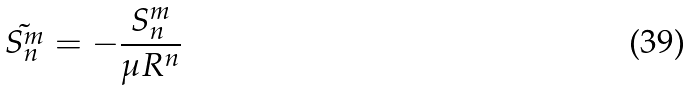<formula> <loc_0><loc_0><loc_500><loc_500>\tilde { S _ { n } ^ { m } } = - \frac { S _ { n } ^ { m } } { \mu R ^ { n } }</formula> 